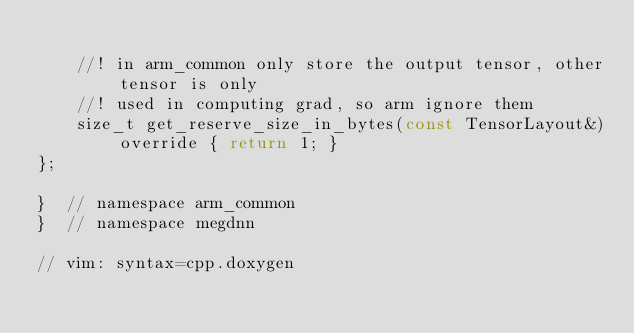<code> <loc_0><loc_0><loc_500><loc_500><_C_>
    //! in arm_common only store the output tensor, other tensor is only
    //! used in computing grad, so arm ignore them
    size_t get_reserve_size_in_bytes(const TensorLayout&) override { return 1; }
};

}  // namespace arm_common
}  // namespace megdnn

// vim: syntax=cpp.doxygen
</code> 